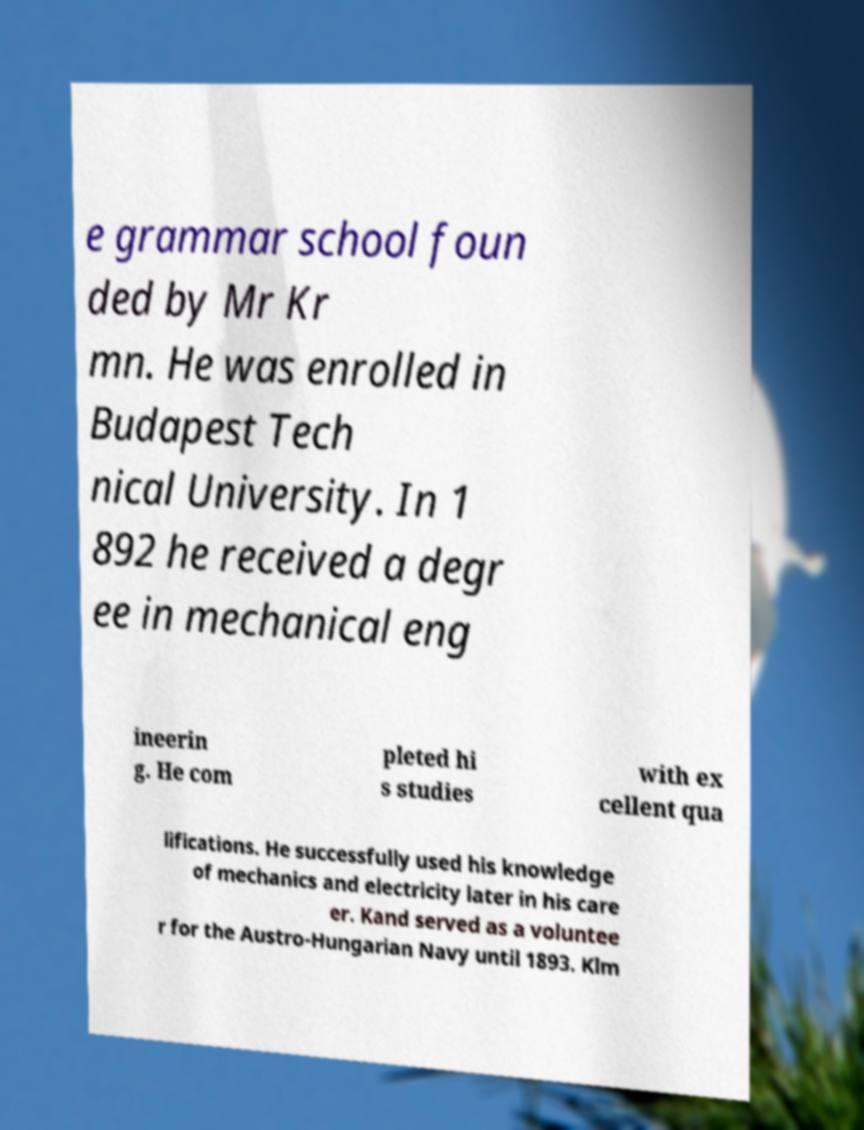I need the written content from this picture converted into text. Can you do that? e grammar school foun ded by Mr Kr mn. He was enrolled in Budapest Tech nical University. In 1 892 he received a degr ee in mechanical eng ineerin g. He com pleted hi s studies with ex cellent qua lifications. He successfully used his knowledge of mechanics and electricity later in his care er. Kand served as a voluntee r for the Austro-Hungarian Navy until 1893. Klm 